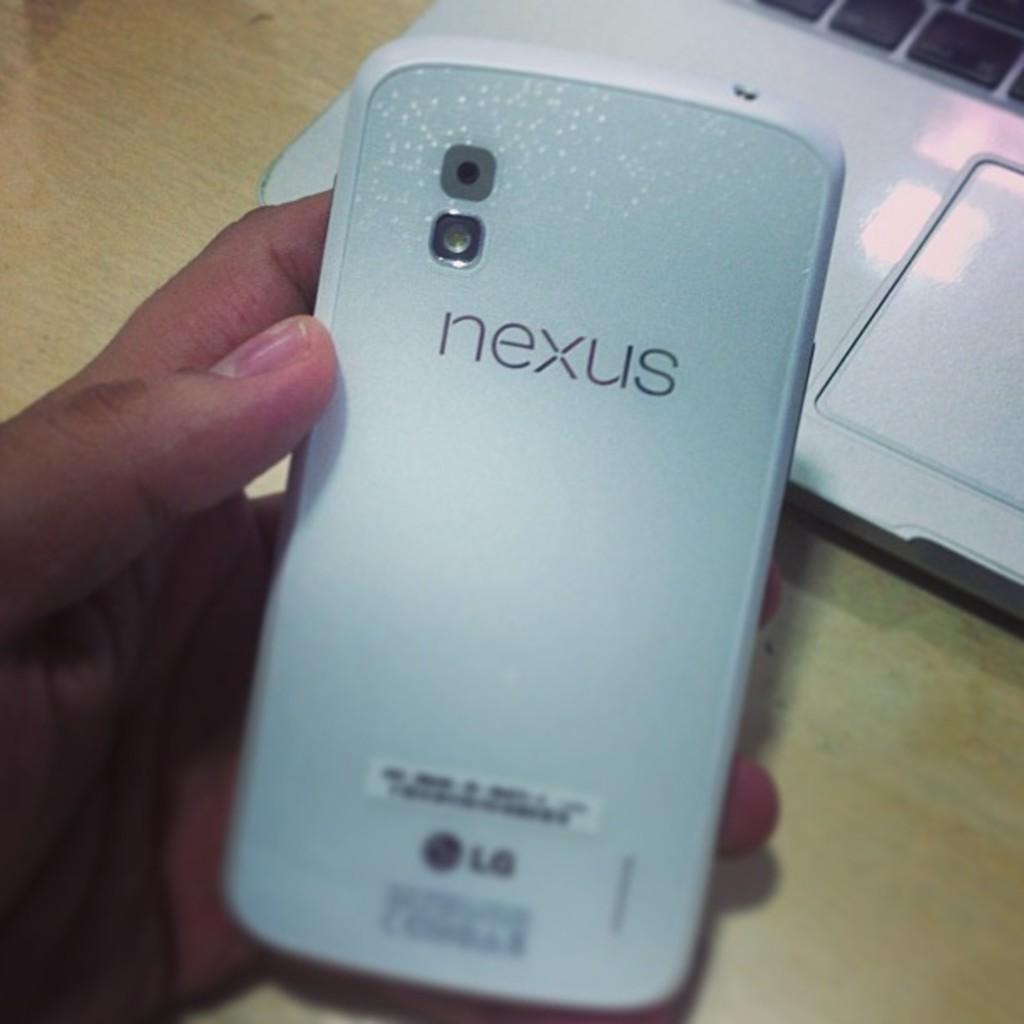Describe this image in one or two sentences. In this picture there is a cell phone in the center of image in a hand and it seems to be a box behind it. 